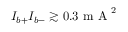Convert formula to latex. <formula><loc_0><loc_0><loc_500><loc_500>I _ { b + } I _ { b - } \gtrsim 0 . 3 m A ^ { 2 }</formula> 